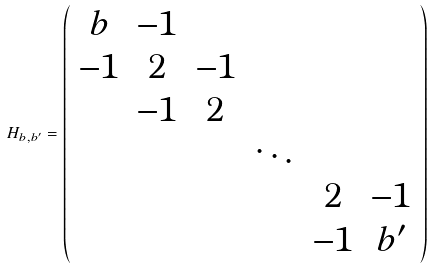<formula> <loc_0><loc_0><loc_500><loc_500>H _ { b , b ^ { \prime } } = \left ( \begin{array} { c c c c c c } b & - 1 & & & & \\ - 1 & 2 & - 1 & & & \\ & - 1 & 2 & & & \\ & & & \ddots & & \\ & & & & 2 & - 1 \\ & & & & - 1 & b ^ { \prime } \end{array} \right )</formula> 